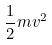Convert formula to latex. <formula><loc_0><loc_0><loc_500><loc_500>\frac { 1 } { 2 } m v ^ { 2 }</formula> 